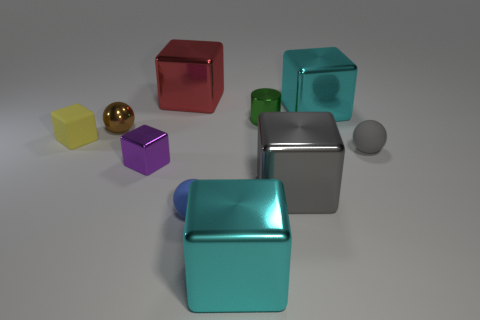Do the red thing and the small green metallic object have the same shape?
Give a very brief answer. No. There is a object that is on the right side of the cyan object behind the purple metallic object; what is it made of?
Your answer should be very brief. Rubber. Is the size of the red cube the same as the gray metallic thing?
Your answer should be compact. Yes. There is a tiny shiny object that is on the right side of the tiny purple object; is there a green metal thing that is in front of it?
Your response must be concise. No. There is a large cyan metallic object that is in front of the brown sphere; what shape is it?
Provide a succinct answer. Cube. How many tiny spheres are left of the large cyan thing that is in front of the tiny shiny cube on the left side of the blue object?
Give a very brief answer. 2. There is a gray block; is its size the same as the object that is to the left of the brown thing?
Offer a very short reply. No. What is the size of the rubber sphere right of the cyan cube that is in front of the big gray metal object?
Your answer should be compact. Small. What number of blocks are the same material as the small gray thing?
Ensure brevity in your answer.  1. Is there a large cyan matte ball?
Give a very brief answer. No. 